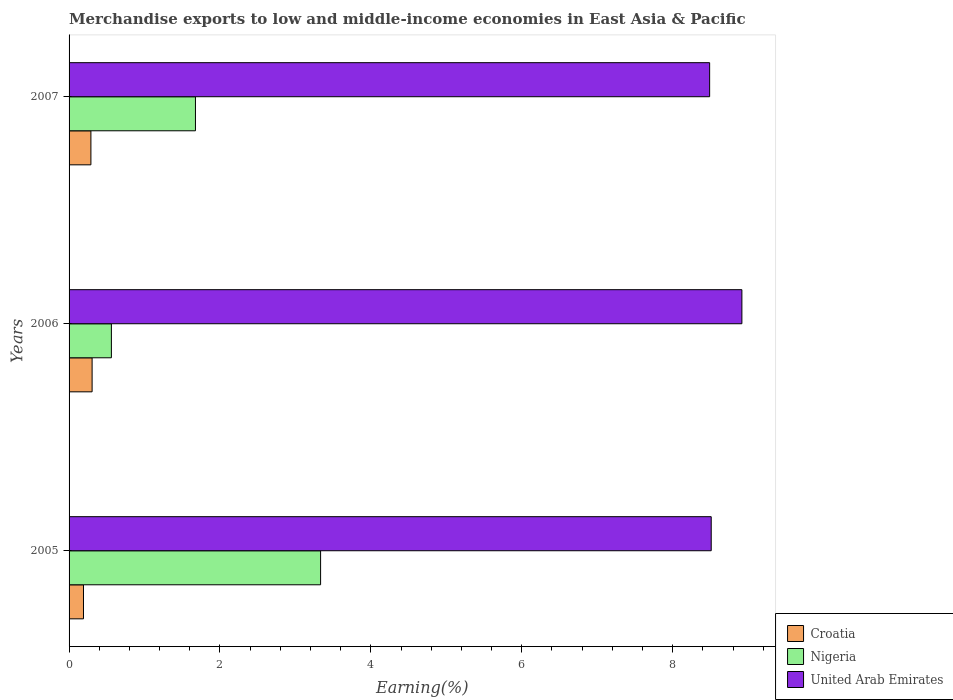Are the number of bars on each tick of the Y-axis equal?
Provide a succinct answer. Yes. How many bars are there on the 3rd tick from the top?
Offer a terse response. 3. How many bars are there on the 2nd tick from the bottom?
Offer a terse response. 3. What is the label of the 1st group of bars from the top?
Your response must be concise. 2007. In how many cases, is the number of bars for a given year not equal to the number of legend labels?
Provide a short and direct response. 0. What is the percentage of amount earned from merchandise exports in Nigeria in 2006?
Give a very brief answer. 0.56. Across all years, what is the maximum percentage of amount earned from merchandise exports in Nigeria?
Your answer should be very brief. 3.33. Across all years, what is the minimum percentage of amount earned from merchandise exports in Nigeria?
Provide a succinct answer. 0.56. In which year was the percentage of amount earned from merchandise exports in Nigeria maximum?
Your response must be concise. 2005. What is the total percentage of amount earned from merchandise exports in United Arab Emirates in the graph?
Provide a succinct answer. 25.92. What is the difference between the percentage of amount earned from merchandise exports in Croatia in 2005 and that in 2006?
Provide a short and direct response. -0.11. What is the difference between the percentage of amount earned from merchandise exports in Nigeria in 2006 and the percentage of amount earned from merchandise exports in Croatia in 2005?
Ensure brevity in your answer.  0.37. What is the average percentage of amount earned from merchandise exports in Croatia per year?
Provide a short and direct response. 0.26. In the year 2006, what is the difference between the percentage of amount earned from merchandise exports in Nigeria and percentage of amount earned from merchandise exports in United Arab Emirates?
Your answer should be very brief. -8.36. What is the ratio of the percentage of amount earned from merchandise exports in Nigeria in 2005 to that in 2007?
Your response must be concise. 1.99. What is the difference between the highest and the second highest percentage of amount earned from merchandise exports in Nigeria?
Give a very brief answer. 1.66. What is the difference between the highest and the lowest percentage of amount earned from merchandise exports in Croatia?
Your answer should be compact. 0.11. In how many years, is the percentage of amount earned from merchandise exports in United Arab Emirates greater than the average percentage of amount earned from merchandise exports in United Arab Emirates taken over all years?
Offer a terse response. 1. Is the sum of the percentage of amount earned from merchandise exports in Croatia in 2005 and 2007 greater than the maximum percentage of amount earned from merchandise exports in Nigeria across all years?
Make the answer very short. No. What does the 1st bar from the top in 2007 represents?
Provide a succinct answer. United Arab Emirates. What does the 2nd bar from the bottom in 2007 represents?
Your answer should be very brief. Nigeria. Is it the case that in every year, the sum of the percentage of amount earned from merchandise exports in United Arab Emirates and percentage of amount earned from merchandise exports in Croatia is greater than the percentage of amount earned from merchandise exports in Nigeria?
Make the answer very short. Yes. How many years are there in the graph?
Your response must be concise. 3. Does the graph contain any zero values?
Make the answer very short. No. Does the graph contain grids?
Ensure brevity in your answer.  No. How many legend labels are there?
Your response must be concise. 3. What is the title of the graph?
Give a very brief answer. Merchandise exports to low and middle-income economies in East Asia & Pacific. What is the label or title of the X-axis?
Offer a very short reply. Earning(%). What is the label or title of the Y-axis?
Offer a terse response. Years. What is the Earning(%) of Croatia in 2005?
Your answer should be compact. 0.19. What is the Earning(%) in Nigeria in 2005?
Your answer should be very brief. 3.33. What is the Earning(%) of United Arab Emirates in 2005?
Ensure brevity in your answer.  8.51. What is the Earning(%) in Croatia in 2006?
Ensure brevity in your answer.  0.31. What is the Earning(%) in Nigeria in 2006?
Keep it short and to the point. 0.56. What is the Earning(%) in United Arab Emirates in 2006?
Ensure brevity in your answer.  8.92. What is the Earning(%) in Croatia in 2007?
Provide a short and direct response. 0.29. What is the Earning(%) in Nigeria in 2007?
Your response must be concise. 1.67. What is the Earning(%) of United Arab Emirates in 2007?
Your answer should be compact. 8.49. Across all years, what is the maximum Earning(%) in Croatia?
Keep it short and to the point. 0.31. Across all years, what is the maximum Earning(%) in Nigeria?
Your answer should be compact. 3.33. Across all years, what is the maximum Earning(%) in United Arab Emirates?
Provide a succinct answer. 8.92. Across all years, what is the minimum Earning(%) in Croatia?
Provide a short and direct response. 0.19. Across all years, what is the minimum Earning(%) in Nigeria?
Provide a succinct answer. 0.56. Across all years, what is the minimum Earning(%) in United Arab Emirates?
Offer a terse response. 8.49. What is the total Earning(%) of Croatia in the graph?
Your answer should be compact. 0.79. What is the total Earning(%) of Nigeria in the graph?
Your answer should be very brief. 5.57. What is the total Earning(%) in United Arab Emirates in the graph?
Make the answer very short. 25.92. What is the difference between the Earning(%) of Croatia in 2005 and that in 2006?
Offer a terse response. -0.11. What is the difference between the Earning(%) of Nigeria in 2005 and that in 2006?
Keep it short and to the point. 2.77. What is the difference between the Earning(%) of United Arab Emirates in 2005 and that in 2006?
Provide a short and direct response. -0.41. What is the difference between the Earning(%) of Croatia in 2005 and that in 2007?
Your response must be concise. -0.1. What is the difference between the Earning(%) in Nigeria in 2005 and that in 2007?
Provide a short and direct response. 1.66. What is the difference between the Earning(%) in United Arab Emirates in 2005 and that in 2007?
Your answer should be very brief. 0.02. What is the difference between the Earning(%) of Croatia in 2006 and that in 2007?
Your answer should be compact. 0.02. What is the difference between the Earning(%) in Nigeria in 2006 and that in 2007?
Keep it short and to the point. -1.11. What is the difference between the Earning(%) in United Arab Emirates in 2006 and that in 2007?
Ensure brevity in your answer.  0.43. What is the difference between the Earning(%) in Croatia in 2005 and the Earning(%) in Nigeria in 2006?
Your answer should be compact. -0.37. What is the difference between the Earning(%) of Croatia in 2005 and the Earning(%) of United Arab Emirates in 2006?
Ensure brevity in your answer.  -8.73. What is the difference between the Earning(%) of Nigeria in 2005 and the Earning(%) of United Arab Emirates in 2006?
Provide a short and direct response. -5.58. What is the difference between the Earning(%) in Croatia in 2005 and the Earning(%) in Nigeria in 2007?
Your answer should be compact. -1.48. What is the difference between the Earning(%) in Croatia in 2005 and the Earning(%) in United Arab Emirates in 2007?
Provide a short and direct response. -8.3. What is the difference between the Earning(%) in Nigeria in 2005 and the Earning(%) in United Arab Emirates in 2007?
Make the answer very short. -5.16. What is the difference between the Earning(%) in Croatia in 2006 and the Earning(%) in Nigeria in 2007?
Your answer should be compact. -1.37. What is the difference between the Earning(%) of Croatia in 2006 and the Earning(%) of United Arab Emirates in 2007?
Provide a short and direct response. -8.18. What is the difference between the Earning(%) in Nigeria in 2006 and the Earning(%) in United Arab Emirates in 2007?
Your response must be concise. -7.93. What is the average Earning(%) of Croatia per year?
Your answer should be compact. 0.26. What is the average Earning(%) of Nigeria per year?
Your response must be concise. 1.86. What is the average Earning(%) of United Arab Emirates per year?
Offer a terse response. 8.64. In the year 2005, what is the difference between the Earning(%) of Croatia and Earning(%) of Nigeria?
Ensure brevity in your answer.  -3.14. In the year 2005, what is the difference between the Earning(%) of Croatia and Earning(%) of United Arab Emirates?
Provide a succinct answer. -8.32. In the year 2005, what is the difference between the Earning(%) of Nigeria and Earning(%) of United Arab Emirates?
Keep it short and to the point. -5.18. In the year 2006, what is the difference between the Earning(%) of Croatia and Earning(%) of Nigeria?
Your answer should be compact. -0.26. In the year 2006, what is the difference between the Earning(%) of Croatia and Earning(%) of United Arab Emirates?
Your response must be concise. -8.61. In the year 2006, what is the difference between the Earning(%) in Nigeria and Earning(%) in United Arab Emirates?
Make the answer very short. -8.36. In the year 2007, what is the difference between the Earning(%) in Croatia and Earning(%) in Nigeria?
Provide a short and direct response. -1.39. In the year 2007, what is the difference between the Earning(%) in Croatia and Earning(%) in United Arab Emirates?
Provide a succinct answer. -8.2. In the year 2007, what is the difference between the Earning(%) in Nigeria and Earning(%) in United Arab Emirates?
Keep it short and to the point. -6.81. What is the ratio of the Earning(%) in Croatia in 2005 to that in 2006?
Provide a succinct answer. 0.63. What is the ratio of the Earning(%) of Nigeria in 2005 to that in 2006?
Ensure brevity in your answer.  5.94. What is the ratio of the Earning(%) in United Arab Emirates in 2005 to that in 2006?
Offer a terse response. 0.95. What is the ratio of the Earning(%) of Croatia in 2005 to that in 2007?
Your response must be concise. 0.66. What is the ratio of the Earning(%) in Nigeria in 2005 to that in 2007?
Your answer should be very brief. 1.99. What is the ratio of the Earning(%) in Croatia in 2006 to that in 2007?
Provide a succinct answer. 1.06. What is the ratio of the Earning(%) in Nigeria in 2006 to that in 2007?
Make the answer very short. 0.33. What is the ratio of the Earning(%) in United Arab Emirates in 2006 to that in 2007?
Your answer should be compact. 1.05. What is the difference between the highest and the second highest Earning(%) of Croatia?
Provide a short and direct response. 0.02. What is the difference between the highest and the second highest Earning(%) of Nigeria?
Make the answer very short. 1.66. What is the difference between the highest and the second highest Earning(%) in United Arab Emirates?
Make the answer very short. 0.41. What is the difference between the highest and the lowest Earning(%) of Croatia?
Ensure brevity in your answer.  0.11. What is the difference between the highest and the lowest Earning(%) in Nigeria?
Offer a terse response. 2.77. What is the difference between the highest and the lowest Earning(%) in United Arab Emirates?
Give a very brief answer. 0.43. 